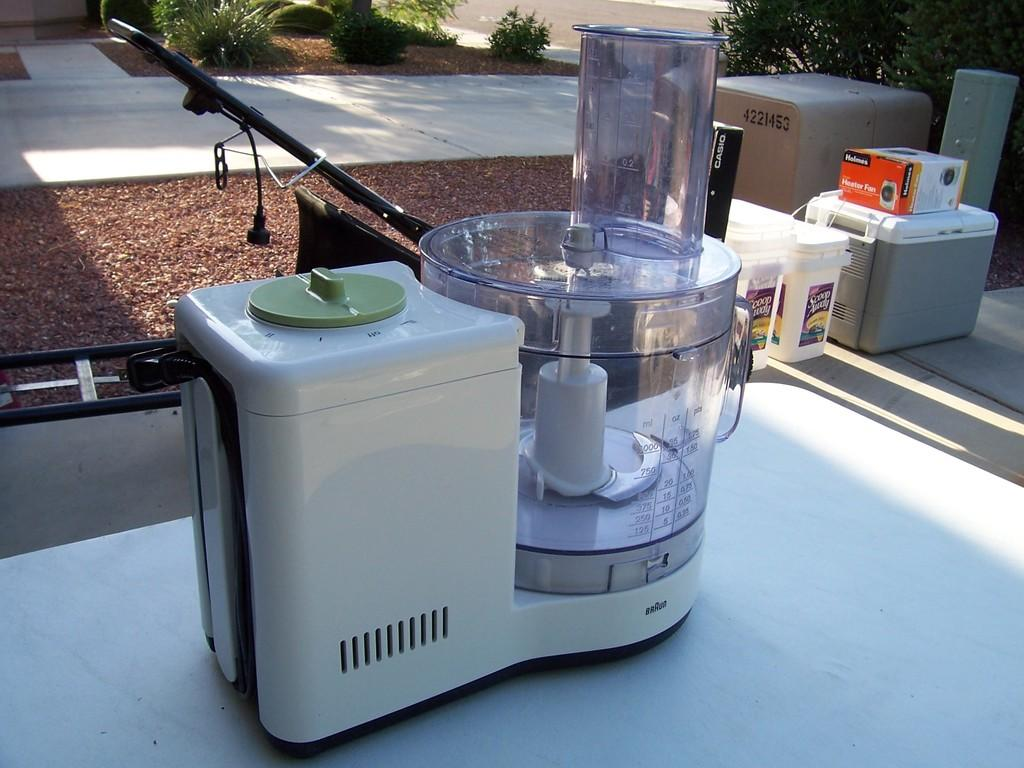What objects are present in the image that resemble storage units? There are containers in the image. What type of natural elements can be seen in the image? There are trees in the image. Can you see any cream being dropped by a spy in the image? There is no cream or spy present in the image. 